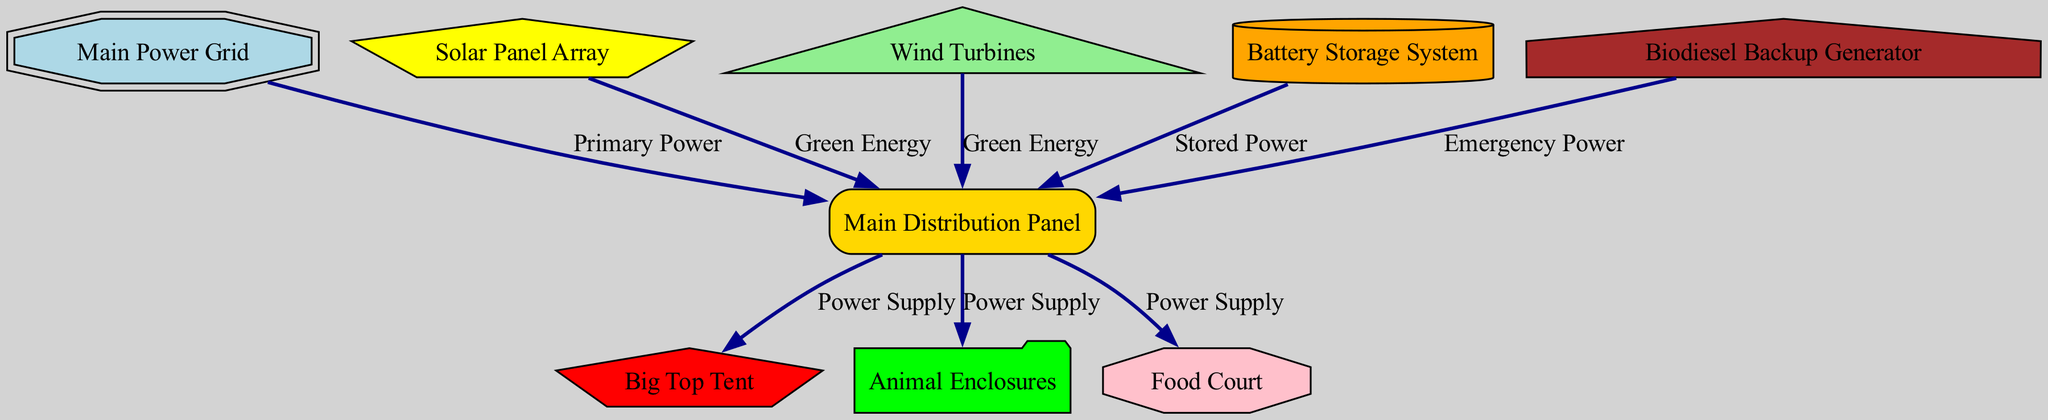What is the total number of nodes in the diagram? The diagram includes nine nodes: Main Power Grid, Solar Panel Array, Wind Turbines, Battery Storage System, Biodiesel Backup Generator, Main Distribution Panel, Big Top Tent, Animal Enclosures, and Food Court. By counting these nodes, we find the total as nine.
Answer: Nine What label is assigned to the biodiesel backup generator? In the diagram, the biodiesel backup generator is labeled "Biodiesel Backup Generator". This can be directly identified from the node with the id "backup_generator".
Answer: Biodiesel Backup Generator Which node receives power labeled as "Stored Power"? The node that receives power labeled as "Stored Power" is the Main Distribution Panel. This connection comes from the Battery Storage System directly to the Main Distribution Panel, as indicated in the edges of the diagram.
Answer: Main Distribution Panel What color represents the solar panel array in the diagram? The solar panel array is represented in yellow color in the diagram. This is specified in the node styles for the id "solar_panels", which directly indicates its fill color.
Answer: Yellow How many types of energy sources are connected to the Main Distribution Panel? There are four types of energy sources connected to the Main Distribution Panel: Main Power Grid (Primary Power), Solar Panels (Green Energy), Wind Turbines (Green Energy), and Battery Storage (Stored Power). By examining the edges, we see these four source connections.
Answer: Four Which node powers the Animal Enclosures? The Animal Enclosures are powered by the Main Distribution Panel. The diagram shows a direct power supply from the distribution panel to the Animal Enclosures according to the edge connections.
Answer: Main Distribution Panel What type of backup generator is used in this layout? The layout employs a Biodiesel Backup Generator as indicated by the label of the corresponding node in the diagram. This can be confirmed by its specific node and label provided.
Answer: Biodiesel Backup Generator Is there a direct power supply to the Food Court? Yes, there is a direct power supply to the Food Court from the Main Distribution Panel, which is marked with a corresponding edge in the diagram. This indicates the pathway for power to reach that node.
Answer: Yes What shape represents the Battery Storage System? The Battery Storage System is represented by a cylinder shape in the diagram. This is detailed in the node styles, where the shape for the id "battery_storage" is specifically assigned as a cylinder.
Answer: Cylinder 